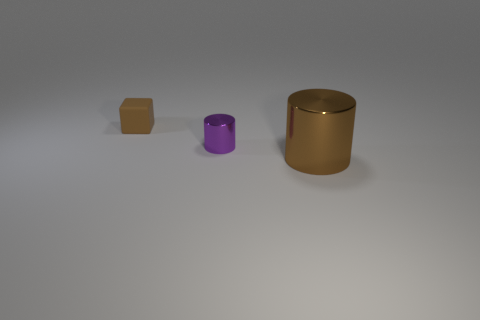Add 2 big cyan rubber objects. How many objects exist? 5 Subtract all cylinders. How many objects are left? 1 Add 1 yellow rubber cylinders. How many yellow rubber cylinders exist? 1 Subtract 0 blue cylinders. How many objects are left? 3 Subtract all brown cylinders. Subtract all tiny brown matte blocks. How many objects are left? 1 Add 1 small rubber cubes. How many small rubber cubes are left? 2 